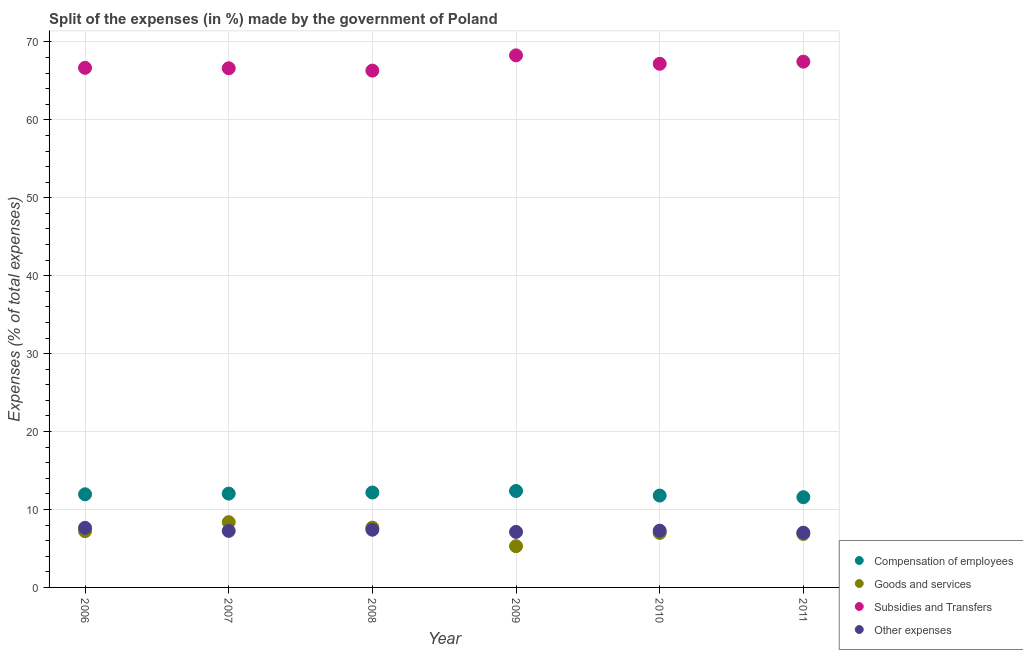Is the number of dotlines equal to the number of legend labels?
Offer a very short reply. Yes. What is the percentage of amount spent on other expenses in 2009?
Provide a succinct answer. 7.13. Across all years, what is the maximum percentage of amount spent on goods and services?
Ensure brevity in your answer.  8.37. Across all years, what is the minimum percentage of amount spent on goods and services?
Offer a very short reply. 5.29. What is the total percentage of amount spent on subsidies in the graph?
Provide a short and direct response. 402.55. What is the difference between the percentage of amount spent on subsidies in 2006 and that in 2011?
Your response must be concise. -0.79. What is the difference between the percentage of amount spent on goods and services in 2011 and the percentage of amount spent on other expenses in 2007?
Your response must be concise. -0.4. What is the average percentage of amount spent on compensation of employees per year?
Offer a terse response. 11.98. In the year 2007, what is the difference between the percentage of amount spent on compensation of employees and percentage of amount spent on subsidies?
Provide a short and direct response. -54.58. What is the ratio of the percentage of amount spent on subsidies in 2007 to that in 2010?
Ensure brevity in your answer.  0.99. Is the difference between the percentage of amount spent on compensation of employees in 2008 and 2009 greater than the difference between the percentage of amount spent on other expenses in 2008 and 2009?
Offer a very short reply. No. What is the difference between the highest and the second highest percentage of amount spent on goods and services?
Your answer should be compact. 0.7. What is the difference between the highest and the lowest percentage of amount spent on other expenses?
Provide a succinct answer. 0.62. In how many years, is the percentage of amount spent on other expenses greater than the average percentage of amount spent on other expenses taken over all years?
Keep it short and to the point. 2. Is the sum of the percentage of amount spent on subsidies in 2009 and 2011 greater than the maximum percentage of amount spent on goods and services across all years?
Ensure brevity in your answer.  Yes. Is it the case that in every year, the sum of the percentage of amount spent on compensation of employees and percentage of amount spent on goods and services is greater than the percentage of amount spent on subsidies?
Offer a terse response. No. Does the percentage of amount spent on subsidies monotonically increase over the years?
Offer a very short reply. No. Is the percentage of amount spent on compensation of employees strictly greater than the percentage of amount spent on subsidies over the years?
Ensure brevity in your answer.  No. Is the percentage of amount spent on subsidies strictly less than the percentage of amount spent on other expenses over the years?
Make the answer very short. No. What is the difference between two consecutive major ticks on the Y-axis?
Offer a very short reply. 10. Are the values on the major ticks of Y-axis written in scientific E-notation?
Give a very brief answer. No. Does the graph contain any zero values?
Your answer should be very brief. No. Does the graph contain grids?
Your answer should be compact. Yes. Where does the legend appear in the graph?
Keep it short and to the point. Bottom right. How many legend labels are there?
Give a very brief answer. 4. How are the legend labels stacked?
Provide a short and direct response. Vertical. What is the title of the graph?
Keep it short and to the point. Split of the expenses (in %) made by the government of Poland. Does "Social Awareness" appear as one of the legend labels in the graph?
Provide a short and direct response. No. What is the label or title of the X-axis?
Your answer should be compact. Year. What is the label or title of the Y-axis?
Make the answer very short. Expenses (% of total expenses). What is the Expenses (% of total expenses) in Compensation of employees in 2006?
Offer a terse response. 11.95. What is the Expenses (% of total expenses) in Goods and services in 2006?
Provide a short and direct response. 7.22. What is the Expenses (% of total expenses) in Subsidies and Transfers in 2006?
Your response must be concise. 66.67. What is the Expenses (% of total expenses) of Other expenses in 2006?
Offer a terse response. 7.64. What is the Expenses (% of total expenses) in Compensation of employees in 2007?
Keep it short and to the point. 12.04. What is the Expenses (% of total expenses) in Goods and services in 2007?
Your answer should be very brief. 8.37. What is the Expenses (% of total expenses) in Subsidies and Transfers in 2007?
Offer a terse response. 66.62. What is the Expenses (% of total expenses) in Other expenses in 2007?
Ensure brevity in your answer.  7.26. What is the Expenses (% of total expenses) in Compensation of employees in 2008?
Your response must be concise. 12.18. What is the Expenses (% of total expenses) in Goods and services in 2008?
Provide a short and direct response. 7.67. What is the Expenses (% of total expenses) in Subsidies and Transfers in 2008?
Ensure brevity in your answer.  66.32. What is the Expenses (% of total expenses) of Other expenses in 2008?
Ensure brevity in your answer.  7.4. What is the Expenses (% of total expenses) in Compensation of employees in 2009?
Your answer should be compact. 12.38. What is the Expenses (% of total expenses) in Goods and services in 2009?
Make the answer very short. 5.29. What is the Expenses (% of total expenses) of Subsidies and Transfers in 2009?
Provide a short and direct response. 68.28. What is the Expenses (% of total expenses) in Other expenses in 2009?
Keep it short and to the point. 7.13. What is the Expenses (% of total expenses) of Compensation of employees in 2010?
Ensure brevity in your answer.  11.79. What is the Expenses (% of total expenses) of Goods and services in 2010?
Make the answer very short. 6.99. What is the Expenses (% of total expenses) in Subsidies and Transfers in 2010?
Your response must be concise. 67.19. What is the Expenses (% of total expenses) in Other expenses in 2010?
Offer a terse response. 7.28. What is the Expenses (% of total expenses) of Compensation of employees in 2011?
Provide a succinct answer. 11.58. What is the Expenses (% of total expenses) of Goods and services in 2011?
Your answer should be compact. 6.86. What is the Expenses (% of total expenses) in Subsidies and Transfers in 2011?
Offer a terse response. 67.47. What is the Expenses (% of total expenses) in Other expenses in 2011?
Make the answer very short. 7.02. Across all years, what is the maximum Expenses (% of total expenses) in Compensation of employees?
Ensure brevity in your answer.  12.38. Across all years, what is the maximum Expenses (% of total expenses) of Goods and services?
Offer a terse response. 8.37. Across all years, what is the maximum Expenses (% of total expenses) of Subsidies and Transfers?
Give a very brief answer. 68.28. Across all years, what is the maximum Expenses (% of total expenses) of Other expenses?
Your answer should be compact. 7.64. Across all years, what is the minimum Expenses (% of total expenses) in Compensation of employees?
Offer a terse response. 11.58. Across all years, what is the minimum Expenses (% of total expenses) in Goods and services?
Offer a terse response. 5.29. Across all years, what is the minimum Expenses (% of total expenses) in Subsidies and Transfers?
Keep it short and to the point. 66.32. Across all years, what is the minimum Expenses (% of total expenses) of Other expenses?
Offer a terse response. 7.02. What is the total Expenses (% of total expenses) in Compensation of employees in the graph?
Provide a short and direct response. 71.91. What is the total Expenses (% of total expenses) of Goods and services in the graph?
Your response must be concise. 42.4. What is the total Expenses (% of total expenses) in Subsidies and Transfers in the graph?
Offer a terse response. 402.55. What is the total Expenses (% of total expenses) in Other expenses in the graph?
Keep it short and to the point. 43.73. What is the difference between the Expenses (% of total expenses) in Compensation of employees in 2006 and that in 2007?
Your answer should be very brief. -0.09. What is the difference between the Expenses (% of total expenses) in Goods and services in 2006 and that in 2007?
Offer a terse response. -1.15. What is the difference between the Expenses (% of total expenses) in Subsidies and Transfers in 2006 and that in 2007?
Provide a succinct answer. 0.05. What is the difference between the Expenses (% of total expenses) in Other expenses in 2006 and that in 2007?
Your response must be concise. 0.39. What is the difference between the Expenses (% of total expenses) of Compensation of employees in 2006 and that in 2008?
Your answer should be compact. -0.23. What is the difference between the Expenses (% of total expenses) of Goods and services in 2006 and that in 2008?
Your answer should be compact. -0.45. What is the difference between the Expenses (% of total expenses) of Subsidies and Transfers in 2006 and that in 2008?
Offer a very short reply. 0.36. What is the difference between the Expenses (% of total expenses) of Other expenses in 2006 and that in 2008?
Make the answer very short. 0.24. What is the difference between the Expenses (% of total expenses) in Compensation of employees in 2006 and that in 2009?
Offer a very short reply. -0.43. What is the difference between the Expenses (% of total expenses) in Goods and services in 2006 and that in 2009?
Your response must be concise. 1.93. What is the difference between the Expenses (% of total expenses) in Subsidies and Transfers in 2006 and that in 2009?
Provide a short and direct response. -1.6. What is the difference between the Expenses (% of total expenses) in Other expenses in 2006 and that in 2009?
Provide a succinct answer. 0.52. What is the difference between the Expenses (% of total expenses) in Compensation of employees in 2006 and that in 2010?
Your response must be concise. 0.16. What is the difference between the Expenses (% of total expenses) in Goods and services in 2006 and that in 2010?
Your answer should be very brief. 0.24. What is the difference between the Expenses (% of total expenses) of Subsidies and Transfers in 2006 and that in 2010?
Keep it short and to the point. -0.52. What is the difference between the Expenses (% of total expenses) in Other expenses in 2006 and that in 2010?
Offer a very short reply. 0.36. What is the difference between the Expenses (% of total expenses) in Compensation of employees in 2006 and that in 2011?
Provide a succinct answer. 0.37. What is the difference between the Expenses (% of total expenses) of Goods and services in 2006 and that in 2011?
Give a very brief answer. 0.36. What is the difference between the Expenses (% of total expenses) in Subsidies and Transfers in 2006 and that in 2011?
Offer a very short reply. -0.79. What is the difference between the Expenses (% of total expenses) in Other expenses in 2006 and that in 2011?
Ensure brevity in your answer.  0.62. What is the difference between the Expenses (% of total expenses) in Compensation of employees in 2007 and that in 2008?
Give a very brief answer. -0.14. What is the difference between the Expenses (% of total expenses) in Goods and services in 2007 and that in 2008?
Keep it short and to the point. 0.7. What is the difference between the Expenses (% of total expenses) in Subsidies and Transfers in 2007 and that in 2008?
Your response must be concise. 0.3. What is the difference between the Expenses (% of total expenses) of Other expenses in 2007 and that in 2008?
Your answer should be very brief. -0.15. What is the difference between the Expenses (% of total expenses) of Compensation of employees in 2007 and that in 2009?
Offer a very short reply. -0.34. What is the difference between the Expenses (% of total expenses) of Goods and services in 2007 and that in 2009?
Give a very brief answer. 3.09. What is the difference between the Expenses (% of total expenses) of Subsidies and Transfers in 2007 and that in 2009?
Ensure brevity in your answer.  -1.65. What is the difference between the Expenses (% of total expenses) in Other expenses in 2007 and that in 2009?
Make the answer very short. 0.13. What is the difference between the Expenses (% of total expenses) in Compensation of employees in 2007 and that in 2010?
Provide a short and direct response. 0.25. What is the difference between the Expenses (% of total expenses) in Goods and services in 2007 and that in 2010?
Your answer should be very brief. 1.39. What is the difference between the Expenses (% of total expenses) in Subsidies and Transfers in 2007 and that in 2010?
Offer a very short reply. -0.57. What is the difference between the Expenses (% of total expenses) in Other expenses in 2007 and that in 2010?
Ensure brevity in your answer.  -0.03. What is the difference between the Expenses (% of total expenses) in Compensation of employees in 2007 and that in 2011?
Provide a short and direct response. 0.46. What is the difference between the Expenses (% of total expenses) in Goods and services in 2007 and that in 2011?
Offer a terse response. 1.52. What is the difference between the Expenses (% of total expenses) in Subsidies and Transfers in 2007 and that in 2011?
Ensure brevity in your answer.  -0.85. What is the difference between the Expenses (% of total expenses) of Other expenses in 2007 and that in 2011?
Your answer should be very brief. 0.23. What is the difference between the Expenses (% of total expenses) of Compensation of employees in 2008 and that in 2009?
Your response must be concise. -0.2. What is the difference between the Expenses (% of total expenses) of Goods and services in 2008 and that in 2009?
Your answer should be compact. 2.38. What is the difference between the Expenses (% of total expenses) in Subsidies and Transfers in 2008 and that in 2009?
Ensure brevity in your answer.  -1.96. What is the difference between the Expenses (% of total expenses) in Other expenses in 2008 and that in 2009?
Your response must be concise. 0.28. What is the difference between the Expenses (% of total expenses) in Compensation of employees in 2008 and that in 2010?
Offer a very short reply. 0.39. What is the difference between the Expenses (% of total expenses) of Goods and services in 2008 and that in 2010?
Offer a very short reply. 0.69. What is the difference between the Expenses (% of total expenses) in Subsidies and Transfers in 2008 and that in 2010?
Offer a terse response. -0.87. What is the difference between the Expenses (% of total expenses) in Other expenses in 2008 and that in 2010?
Offer a very short reply. 0.12. What is the difference between the Expenses (% of total expenses) in Compensation of employees in 2008 and that in 2011?
Your response must be concise. 0.6. What is the difference between the Expenses (% of total expenses) in Goods and services in 2008 and that in 2011?
Your response must be concise. 0.81. What is the difference between the Expenses (% of total expenses) of Subsidies and Transfers in 2008 and that in 2011?
Make the answer very short. -1.15. What is the difference between the Expenses (% of total expenses) of Other expenses in 2008 and that in 2011?
Give a very brief answer. 0.38. What is the difference between the Expenses (% of total expenses) of Compensation of employees in 2009 and that in 2010?
Give a very brief answer. 0.59. What is the difference between the Expenses (% of total expenses) of Goods and services in 2009 and that in 2010?
Provide a short and direct response. -1.7. What is the difference between the Expenses (% of total expenses) in Subsidies and Transfers in 2009 and that in 2010?
Give a very brief answer. 1.08. What is the difference between the Expenses (% of total expenses) in Other expenses in 2009 and that in 2010?
Offer a very short reply. -0.16. What is the difference between the Expenses (% of total expenses) of Compensation of employees in 2009 and that in 2011?
Provide a short and direct response. 0.8. What is the difference between the Expenses (% of total expenses) in Goods and services in 2009 and that in 2011?
Provide a short and direct response. -1.57. What is the difference between the Expenses (% of total expenses) of Subsidies and Transfers in 2009 and that in 2011?
Give a very brief answer. 0.81. What is the difference between the Expenses (% of total expenses) in Other expenses in 2009 and that in 2011?
Your answer should be compact. 0.1. What is the difference between the Expenses (% of total expenses) in Compensation of employees in 2010 and that in 2011?
Your answer should be very brief. 0.21. What is the difference between the Expenses (% of total expenses) of Goods and services in 2010 and that in 2011?
Ensure brevity in your answer.  0.13. What is the difference between the Expenses (% of total expenses) in Subsidies and Transfers in 2010 and that in 2011?
Keep it short and to the point. -0.28. What is the difference between the Expenses (% of total expenses) in Other expenses in 2010 and that in 2011?
Provide a succinct answer. 0.26. What is the difference between the Expenses (% of total expenses) of Compensation of employees in 2006 and the Expenses (% of total expenses) of Goods and services in 2007?
Give a very brief answer. 3.58. What is the difference between the Expenses (% of total expenses) in Compensation of employees in 2006 and the Expenses (% of total expenses) in Subsidies and Transfers in 2007?
Give a very brief answer. -54.67. What is the difference between the Expenses (% of total expenses) of Compensation of employees in 2006 and the Expenses (% of total expenses) of Other expenses in 2007?
Provide a succinct answer. 4.7. What is the difference between the Expenses (% of total expenses) in Goods and services in 2006 and the Expenses (% of total expenses) in Subsidies and Transfers in 2007?
Ensure brevity in your answer.  -59.4. What is the difference between the Expenses (% of total expenses) of Goods and services in 2006 and the Expenses (% of total expenses) of Other expenses in 2007?
Your answer should be compact. -0.03. What is the difference between the Expenses (% of total expenses) in Subsidies and Transfers in 2006 and the Expenses (% of total expenses) in Other expenses in 2007?
Make the answer very short. 59.42. What is the difference between the Expenses (% of total expenses) of Compensation of employees in 2006 and the Expenses (% of total expenses) of Goods and services in 2008?
Offer a very short reply. 4.28. What is the difference between the Expenses (% of total expenses) in Compensation of employees in 2006 and the Expenses (% of total expenses) in Subsidies and Transfers in 2008?
Ensure brevity in your answer.  -54.37. What is the difference between the Expenses (% of total expenses) in Compensation of employees in 2006 and the Expenses (% of total expenses) in Other expenses in 2008?
Offer a very short reply. 4.55. What is the difference between the Expenses (% of total expenses) in Goods and services in 2006 and the Expenses (% of total expenses) in Subsidies and Transfers in 2008?
Offer a terse response. -59.1. What is the difference between the Expenses (% of total expenses) of Goods and services in 2006 and the Expenses (% of total expenses) of Other expenses in 2008?
Your answer should be compact. -0.18. What is the difference between the Expenses (% of total expenses) of Subsidies and Transfers in 2006 and the Expenses (% of total expenses) of Other expenses in 2008?
Your answer should be very brief. 59.27. What is the difference between the Expenses (% of total expenses) of Compensation of employees in 2006 and the Expenses (% of total expenses) of Goods and services in 2009?
Keep it short and to the point. 6.66. What is the difference between the Expenses (% of total expenses) of Compensation of employees in 2006 and the Expenses (% of total expenses) of Subsidies and Transfers in 2009?
Give a very brief answer. -56.32. What is the difference between the Expenses (% of total expenses) of Compensation of employees in 2006 and the Expenses (% of total expenses) of Other expenses in 2009?
Ensure brevity in your answer.  4.83. What is the difference between the Expenses (% of total expenses) in Goods and services in 2006 and the Expenses (% of total expenses) in Subsidies and Transfers in 2009?
Your answer should be very brief. -61.05. What is the difference between the Expenses (% of total expenses) of Goods and services in 2006 and the Expenses (% of total expenses) of Other expenses in 2009?
Provide a succinct answer. 0.1. What is the difference between the Expenses (% of total expenses) in Subsidies and Transfers in 2006 and the Expenses (% of total expenses) in Other expenses in 2009?
Provide a short and direct response. 59.55. What is the difference between the Expenses (% of total expenses) of Compensation of employees in 2006 and the Expenses (% of total expenses) of Goods and services in 2010?
Offer a terse response. 4.96. What is the difference between the Expenses (% of total expenses) in Compensation of employees in 2006 and the Expenses (% of total expenses) in Subsidies and Transfers in 2010?
Keep it short and to the point. -55.24. What is the difference between the Expenses (% of total expenses) in Compensation of employees in 2006 and the Expenses (% of total expenses) in Other expenses in 2010?
Give a very brief answer. 4.67. What is the difference between the Expenses (% of total expenses) of Goods and services in 2006 and the Expenses (% of total expenses) of Subsidies and Transfers in 2010?
Keep it short and to the point. -59.97. What is the difference between the Expenses (% of total expenses) of Goods and services in 2006 and the Expenses (% of total expenses) of Other expenses in 2010?
Offer a very short reply. -0.06. What is the difference between the Expenses (% of total expenses) of Subsidies and Transfers in 2006 and the Expenses (% of total expenses) of Other expenses in 2010?
Give a very brief answer. 59.39. What is the difference between the Expenses (% of total expenses) of Compensation of employees in 2006 and the Expenses (% of total expenses) of Goods and services in 2011?
Your answer should be very brief. 5.09. What is the difference between the Expenses (% of total expenses) of Compensation of employees in 2006 and the Expenses (% of total expenses) of Subsidies and Transfers in 2011?
Ensure brevity in your answer.  -55.52. What is the difference between the Expenses (% of total expenses) in Compensation of employees in 2006 and the Expenses (% of total expenses) in Other expenses in 2011?
Your answer should be compact. 4.93. What is the difference between the Expenses (% of total expenses) of Goods and services in 2006 and the Expenses (% of total expenses) of Subsidies and Transfers in 2011?
Your response must be concise. -60.25. What is the difference between the Expenses (% of total expenses) in Goods and services in 2006 and the Expenses (% of total expenses) in Other expenses in 2011?
Give a very brief answer. 0.2. What is the difference between the Expenses (% of total expenses) of Subsidies and Transfers in 2006 and the Expenses (% of total expenses) of Other expenses in 2011?
Offer a terse response. 59.65. What is the difference between the Expenses (% of total expenses) in Compensation of employees in 2007 and the Expenses (% of total expenses) in Goods and services in 2008?
Make the answer very short. 4.36. What is the difference between the Expenses (% of total expenses) in Compensation of employees in 2007 and the Expenses (% of total expenses) in Subsidies and Transfers in 2008?
Provide a succinct answer. -54.28. What is the difference between the Expenses (% of total expenses) of Compensation of employees in 2007 and the Expenses (% of total expenses) of Other expenses in 2008?
Offer a very short reply. 4.63. What is the difference between the Expenses (% of total expenses) in Goods and services in 2007 and the Expenses (% of total expenses) in Subsidies and Transfers in 2008?
Make the answer very short. -57.94. What is the difference between the Expenses (% of total expenses) in Goods and services in 2007 and the Expenses (% of total expenses) in Other expenses in 2008?
Provide a succinct answer. 0.97. What is the difference between the Expenses (% of total expenses) in Subsidies and Transfers in 2007 and the Expenses (% of total expenses) in Other expenses in 2008?
Your answer should be compact. 59.22. What is the difference between the Expenses (% of total expenses) in Compensation of employees in 2007 and the Expenses (% of total expenses) in Goods and services in 2009?
Give a very brief answer. 6.75. What is the difference between the Expenses (% of total expenses) in Compensation of employees in 2007 and the Expenses (% of total expenses) in Subsidies and Transfers in 2009?
Your answer should be very brief. -56.24. What is the difference between the Expenses (% of total expenses) of Compensation of employees in 2007 and the Expenses (% of total expenses) of Other expenses in 2009?
Ensure brevity in your answer.  4.91. What is the difference between the Expenses (% of total expenses) of Goods and services in 2007 and the Expenses (% of total expenses) of Subsidies and Transfers in 2009?
Make the answer very short. -59.9. What is the difference between the Expenses (% of total expenses) in Goods and services in 2007 and the Expenses (% of total expenses) in Other expenses in 2009?
Give a very brief answer. 1.25. What is the difference between the Expenses (% of total expenses) of Subsidies and Transfers in 2007 and the Expenses (% of total expenses) of Other expenses in 2009?
Make the answer very short. 59.5. What is the difference between the Expenses (% of total expenses) in Compensation of employees in 2007 and the Expenses (% of total expenses) in Goods and services in 2010?
Offer a terse response. 5.05. What is the difference between the Expenses (% of total expenses) of Compensation of employees in 2007 and the Expenses (% of total expenses) of Subsidies and Transfers in 2010?
Offer a terse response. -55.15. What is the difference between the Expenses (% of total expenses) in Compensation of employees in 2007 and the Expenses (% of total expenses) in Other expenses in 2010?
Your answer should be very brief. 4.76. What is the difference between the Expenses (% of total expenses) of Goods and services in 2007 and the Expenses (% of total expenses) of Subsidies and Transfers in 2010?
Provide a succinct answer. -58.82. What is the difference between the Expenses (% of total expenses) of Goods and services in 2007 and the Expenses (% of total expenses) of Other expenses in 2010?
Offer a terse response. 1.09. What is the difference between the Expenses (% of total expenses) in Subsidies and Transfers in 2007 and the Expenses (% of total expenses) in Other expenses in 2010?
Provide a short and direct response. 59.34. What is the difference between the Expenses (% of total expenses) in Compensation of employees in 2007 and the Expenses (% of total expenses) in Goods and services in 2011?
Your answer should be very brief. 5.18. What is the difference between the Expenses (% of total expenses) in Compensation of employees in 2007 and the Expenses (% of total expenses) in Subsidies and Transfers in 2011?
Ensure brevity in your answer.  -55.43. What is the difference between the Expenses (% of total expenses) in Compensation of employees in 2007 and the Expenses (% of total expenses) in Other expenses in 2011?
Make the answer very short. 5.01. What is the difference between the Expenses (% of total expenses) of Goods and services in 2007 and the Expenses (% of total expenses) of Subsidies and Transfers in 2011?
Keep it short and to the point. -59.09. What is the difference between the Expenses (% of total expenses) in Goods and services in 2007 and the Expenses (% of total expenses) in Other expenses in 2011?
Your answer should be very brief. 1.35. What is the difference between the Expenses (% of total expenses) in Subsidies and Transfers in 2007 and the Expenses (% of total expenses) in Other expenses in 2011?
Ensure brevity in your answer.  59.6. What is the difference between the Expenses (% of total expenses) of Compensation of employees in 2008 and the Expenses (% of total expenses) of Goods and services in 2009?
Offer a terse response. 6.89. What is the difference between the Expenses (% of total expenses) of Compensation of employees in 2008 and the Expenses (% of total expenses) of Subsidies and Transfers in 2009?
Offer a terse response. -56.1. What is the difference between the Expenses (% of total expenses) of Compensation of employees in 2008 and the Expenses (% of total expenses) of Other expenses in 2009?
Make the answer very short. 5.05. What is the difference between the Expenses (% of total expenses) in Goods and services in 2008 and the Expenses (% of total expenses) in Subsidies and Transfers in 2009?
Offer a very short reply. -60.6. What is the difference between the Expenses (% of total expenses) in Goods and services in 2008 and the Expenses (% of total expenses) in Other expenses in 2009?
Your answer should be very brief. 0.55. What is the difference between the Expenses (% of total expenses) in Subsidies and Transfers in 2008 and the Expenses (% of total expenses) in Other expenses in 2009?
Provide a short and direct response. 59.19. What is the difference between the Expenses (% of total expenses) in Compensation of employees in 2008 and the Expenses (% of total expenses) in Goods and services in 2010?
Provide a short and direct response. 5.19. What is the difference between the Expenses (% of total expenses) in Compensation of employees in 2008 and the Expenses (% of total expenses) in Subsidies and Transfers in 2010?
Your response must be concise. -55.01. What is the difference between the Expenses (% of total expenses) of Compensation of employees in 2008 and the Expenses (% of total expenses) of Other expenses in 2010?
Ensure brevity in your answer.  4.9. What is the difference between the Expenses (% of total expenses) in Goods and services in 2008 and the Expenses (% of total expenses) in Subsidies and Transfers in 2010?
Your response must be concise. -59.52. What is the difference between the Expenses (% of total expenses) in Goods and services in 2008 and the Expenses (% of total expenses) in Other expenses in 2010?
Ensure brevity in your answer.  0.39. What is the difference between the Expenses (% of total expenses) in Subsidies and Transfers in 2008 and the Expenses (% of total expenses) in Other expenses in 2010?
Make the answer very short. 59.04. What is the difference between the Expenses (% of total expenses) of Compensation of employees in 2008 and the Expenses (% of total expenses) of Goods and services in 2011?
Your answer should be very brief. 5.32. What is the difference between the Expenses (% of total expenses) in Compensation of employees in 2008 and the Expenses (% of total expenses) in Subsidies and Transfers in 2011?
Keep it short and to the point. -55.29. What is the difference between the Expenses (% of total expenses) of Compensation of employees in 2008 and the Expenses (% of total expenses) of Other expenses in 2011?
Keep it short and to the point. 5.15. What is the difference between the Expenses (% of total expenses) in Goods and services in 2008 and the Expenses (% of total expenses) in Subsidies and Transfers in 2011?
Provide a short and direct response. -59.8. What is the difference between the Expenses (% of total expenses) in Goods and services in 2008 and the Expenses (% of total expenses) in Other expenses in 2011?
Provide a short and direct response. 0.65. What is the difference between the Expenses (% of total expenses) in Subsidies and Transfers in 2008 and the Expenses (% of total expenses) in Other expenses in 2011?
Provide a succinct answer. 59.3. What is the difference between the Expenses (% of total expenses) in Compensation of employees in 2009 and the Expenses (% of total expenses) in Goods and services in 2010?
Give a very brief answer. 5.39. What is the difference between the Expenses (% of total expenses) of Compensation of employees in 2009 and the Expenses (% of total expenses) of Subsidies and Transfers in 2010?
Give a very brief answer. -54.82. What is the difference between the Expenses (% of total expenses) in Compensation of employees in 2009 and the Expenses (% of total expenses) in Other expenses in 2010?
Your answer should be compact. 5.1. What is the difference between the Expenses (% of total expenses) in Goods and services in 2009 and the Expenses (% of total expenses) in Subsidies and Transfers in 2010?
Keep it short and to the point. -61.9. What is the difference between the Expenses (% of total expenses) in Goods and services in 2009 and the Expenses (% of total expenses) in Other expenses in 2010?
Offer a very short reply. -1.99. What is the difference between the Expenses (% of total expenses) in Subsidies and Transfers in 2009 and the Expenses (% of total expenses) in Other expenses in 2010?
Provide a succinct answer. 60.99. What is the difference between the Expenses (% of total expenses) of Compensation of employees in 2009 and the Expenses (% of total expenses) of Goods and services in 2011?
Your response must be concise. 5.52. What is the difference between the Expenses (% of total expenses) in Compensation of employees in 2009 and the Expenses (% of total expenses) in Subsidies and Transfers in 2011?
Your answer should be very brief. -55.09. What is the difference between the Expenses (% of total expenses) of Compensation of employees in 2009 and the Expenses (% of total expenses) of Other expenses in 2011?
Your answer should be compact. 5.35. What is the difference between the Expenses (% of total expenses) of Goods and services in 2009 and the Expenses (% of total expenses) of Subsidies and Transfers in 2011?
Make the answer very short. -62.18. What is the difference between the Expenses (% of total expenses) in Goods and services in 2009 and the Expenses (% of total expenses) in Other expenses in 2011?
Offer a terse response. -1.74. What is the difference between the Expenses (% of total expenses) in Subsidies and Transfers in 2009 and the Expenses (% of total expenses) in Other expenses in 2011?
Provide a succinct answer. 61.25. What is the difference between the Expenses (% of total expenses) in Compensation of employees in 2010 and the Expenses (% of total expenses) in Goods and services in 2011?
Ensure brevity in your answer.  4.93. What is the difference between the Expenses (% of total expenses) of Compensation of employees in 2010 and the Expenses (% of total expenses) of Subsidies and Transfers in 2011?
Provide a succinct answer. -55.68. What is the difference between the Expenses (% of total expenses) of Compensation of employees in 2010 and the Expenses (% of total expenses) of Other expenses in 2011?
Make the answer very short. 4.76. What is the difference between the Expenses (% of total expenses) in Goods and services in 2010 and the Expenses (% of total expenses) in Subsidies and Transfers in 2011?
Make the answer very short. -60.48. What is the difference between the Expenses (% of total expenses) of Goods and services in 2010 and the Expenses (% of total expenses) of Other expenses in 2011?
Ensure brevity in your answer.  -0.04. What is the difference between the Expenses (% of total expenses) in Subsidies and Transfers in 2010 and the Expenses (% of total expenses) in Other expenses in 2011?
Provide a succinct answer. 60.17. What is the average Expenses (% of total expenses) in Compensation of employees per year?
Offer a terse response. 11.98. What is the average Expenses (% of total expenses) of Goods and services per year?
Your answer should be very brief. 7.07. What is the average Expenses (% of total expenses) of Subsidies and Transfers per year?
Offer a very short reply. 67.09. What is the average Expenses (% of total expenses) of Other expenses per year?
Keep it short and to the point. 7.29. In the year 2006, what is the difference between the Expenses (% of total expenses) of Compensation of employees and Expenses (% of total expenses) of Goods and services?
Your response must be concise. 4.73. In the year 2006, what is the difference between the Expenses (% of total expenses) in Compensation of employees and Expenses (% of total expenses) in Subsidies and Transfers?
Ensure brevity in your answer.  -54.72. In the year 2006, what is the difference between the Expenses (% of total expenses) of Compensation of employees and Expenses (% of total expenses) of Other expenses?
Your response must be concise. 4.31. In the year 2006, what is the difference between the Expenses (% of total expenses) in Goods and services and Expenses (% of total expenses) in Subsidies and Transfers?
Provide a short and direct response. -59.45. In the year 2006, what is the difference between the Expenses (% of total expenses) in Goods and services and Expenses (% of total expenses) in Other expenses?
Provide a succinct answer. -0.42. In the year 2006, what is the difference between the Expenses (% of total expenses) of Subsidies and Transfers and Expenses (% of total expenses) of Other expenses?
Your response must be concise. 59.03. In the year 2007, what is the difference between the Expenses (% of total expenses) of Compensation of employees and Expenses (% of total expenses) of Goods and services?
Keep it short and to the point. 3.66. In the year 2007, what is the difference between the Expenses (% of total expenses) of Compensation of employees and Expenses (% of total expenses) of Subsidies and Transfers?
Make the answer very short. -54.58. In the year 2007, what is the difference between the Expenses (% of total expenses) in Compensation of employees and Expenses (% of total expenses) in Other expenses?
Your response must be concise. 4.78. In the year 2007, what is the difference between the Expenses (% of total expenses) of Goods and services and Expenses (% of total expenses) of Subsidies and Transfers?
Your answer should be very brief. -58.25. In the year 2007, what is the difference between the Expenses (% of total expenses) in Goods and services and Expenses (% of total expenses) in Other expenses?
Your answer should be compact. 1.12. In the year 2007, what is the difference between the Expenses (% of total expenses) in Subsidies and Transfers and Expenses (% of total expenses) in Other expenses?
Make the answer very short. 59.37. In the year 2008, what is the difference between the Expenses (% of total expenses) in Compensation of employees and Expenses (% of total expenses) in Goods and services?
Ensure brevity in your answer.  4.51. In the year 2008, what is the difference between the Expenses (% of total expenses) in Compensation of employees and Expenses (% of total expenses) in Subsidies and Transfers?
Provide a succinct answer. -54.14. In the year 2008, what is the difference between the Expenses (% of total expenses) of Compensation of employees and Expenses (% of total expenses) of Other expenses?
Your answer should be very brief. 4.77. In the year 2008, what is the difference between the Expenses (% of total expenses) in Goods and services and Expenses (% of total expenses) in Subsidies and Transfers?
Keep it short and to the point. -58.65. In the year 2008, what is the difference between the Expenses (% of total expenses) in Goods and services and Expenses (% of total expenses) in Other expenses?
Make the answer very short. 0.27. In the year 2008, what is the difference between the Expenses (% of total expenses) in Subsidies and Transfers and Expenses (% of total expenses) in Other expenses?
Offer a very short reply. 58.91. In the year 2009, what is the difference between the Expenses (% of total expenses) of Compensation of employees and Expenses (% of total expenses) of Goods and services?
Offer a very short reply. 7.09. In the year 2009, what is the difference between the Expenses (% of total expenses) in Compensation of employees and Expenses (% of total expenses) in Subsidies and Transfers?
Your answer should be compact. -55.9. In the year 2009, what is the difference between the Expenses (% of total expenses) of Compensation of employees and Expenses (% of total expenses) of Other expenses?
Provide a short and direct response. 5.25. In the year 2009, what is the difference between the Expenses (% of total expenses) of Goods and services and Expenses (% of total expenses) of Subsidies and Transfers?
Make the answer very short. -62.99. In the year 2009, what is the difference between the Expenses (% of total expenses) of Goods and services and Expenses (% of total expenses) of Other expenses?
Your answer should be very brief. -1.84. In the year 2009, what is the difference between the Expenses (% of total expenses) in Subsidies and Transfers and Expenses (% of total expenses) in Other expenses?
Your answer should be compact. 61.15. In the year 2010, what is the difference between the Expenses (% of total expenses) in Compensation of employees and Expenses (% of total expenses) in Goods and services?
Your response must be concise. 4.8. In the year 2010, what is the difference between the Expenses (% of total expenses) of Compensation of employees and Expenses (% of total expenses) of Subsidies and Transfers?
Offer a terse response. -55.4. In the year 2010, what is the difference between the Expenses (% of total expenses) of Compensation of employees and Expenses (% of total expenses) of Other expenses?
Your answer should be compact. 4.51. In the year 2010, what is the difference between the Expenses (% of total expenses) of Goods and services and Expenses (% of total expenses) of Subsidies and Transfers?
Your response must be concise. -60.21. In the year 2010, what is the difference between the Expenses (% of total expenses) of Goods and services and Expenses (% of total expenses) of Other expenses?
Provide a short and direct response. -0.29. In the year 2010, what is the difference between the Expenses (% of total expenses) of Subsidies and Transfers and Expenses (% of total expenses) of Other expenses?
Ensure brevity in your answer.  59.91. In the year 2011, what is the difference between the Expenses (% of total expenses) in Compensation of employees and Expenses (% of total expenses) in Goods and services?
Provide a succinct answer. 4.72. In the year 2011, what is the difference between the Expenses (% of total expenses) of Compensation of employees and Expenses (% of total expenses) of Subsidies and Transfers?
Your answer should be compact. -55.89. In the year 2011, what is the difference between the Expenses (% of total expenses) in Compensation of employees and Expenses (% of total expenses) in Other expenses?
Offer a very short reply. 4.55. In the year 2011, what is the difference between the Expenses (% of total expenses) of Goods and services and Expenses (% of total expenses) of Subsidies and Transfers?
Make the answer very short. -60.61. In the year 2011, what is the difference between the Expenses (% of total expenses) of Goods and services and Expenses (% of total expenses) of Other expenses?
Provide a short and direct response. -0.17. In the year 2011, what is the difference between the Expenses (% of total expenses) of Subsidies and Transfers and Expenses (% of total expenses) of Other expenses?
Offer a terse response. 60.45. What is the ratio of the Expenses (% of total expenses) in Compensation of employees in 2006 to that in 2007?
Keep it short and to the point. 0.99. What is the ratio of the Expenses (% of total expenses) in Goods and services in 2006 to that in 2007?
Keep it short and to the point. 0.86. What is the ratio of the Expenses (% of total expenses) of Other expenses in 2006 to that in 2007?
Give a very brief answer. 1.05. What is the ratio of the Expenses (% of total expenses) of Compensation of employees in 2006 to that in 2008?
Provide a short and direct response. 0.98. What is the ratio of the Expenses (% of total expenses) of Subsidies and Transfers in 2006 to that in 2008?
Make the answer very short. 1.01. What is the ratio of the Expenses (% of total expenses) in Other expenses in 2006 to that in 2008?
Give a very brief answer. 1.03. What is the ratio of the Expenses (% of total expenses) of Compensation of employees in 2006 to that in 2009?
Provide a short and direct response. 0.97. What is the ratio of the Expenses (% of total expenses) in Goods and services in 2006 to that in 2009?
Your answer should be compact. 1.37. What is the ratio of the Expenses (% of total expenses) of Subsidies and Transfers in 2006 to that in 2009?
Offer a very short reply. 0.98. What is the ratio of the Expenses (% of total expenses) of Other expenses in 2006 to that in 2009?
Ensure brevity in your answer.  1.07. What is the ratio of the Expenses (% of total expenses) of Compensation of employees in 2006 to that in 2010?
Provide a succinct answer. 1.01. What is the ratio of the Expenses (% of total expenses) in Goods and services in 2006 to that in 2010?
Your answer should be very brief. 1.03. What is the ratio of the Expenses (% of total expenses) in Subsidies and Transfers in 2006 to that in 2010?
Ensure brevity in your answer.  0.99. What is the ratio of the Expenses (% of total expenses) in Other expenses in 2006 to that in 2010?
Ensure brevity in your answer.  1.05. What is the ratio of the Expenses (% of total expenses) in Compensation of employees in 2006 to that in 2011?
Keep it short and to the point. 1.03. What is the ratio of the Expenses (% of total expenses) in Goods and services in 2006 to that in 2011?
Make the answer very short. 1.05. What is the ratio of the Expenses (% of total expenses) of Subsidies and Transfers in 2006 to that in 2011?
Keep it short and to the point. 0.99. What is the ratio of the Expenses (% of total expenses) of Other expenses in 2006 to that in 2011?
Ensure brevity in your answer.  1.09. What is the ratio of the Expenses (% of total expenses) of Compensation of employees in 2007 to that in 2008?
Provide a short and direct response. 0.99. What is the ratio of the Expenses (% of total expenses) in Goods and services in 2007 to that in 2008?
Make the answer very short. 1.09. What is the ratio of the Expenses (% of total expenses) in Other expenses in 2007 to that in 2008?
Offer a terse response. 0.98. What is the ratio of the Expenses (% of total expenses) of Compensation of employees in 2007 to that in 2009?
Ensure brevity in your answer.  0.97. What is the ratio of the Expenses (% of total expenses) of Goods and services in 2007 to that in 2009?
Your answer should be very brief. 1.58. What is the ratio of the Expenses (% of total expenses) in Subsidies and Transfers in 2007 to that in 2009?
Your answer should be very brief. 0.98. What is the ratio of the Expenses (% of total expenses) of Other expenses in 2007 to that in 2009?
Ensure brevity in your answer.  1.02. What is the ratio of the Expenses (% of total expenses) in Compensation of employees in 2007 to that in 2010?
Make the answer very short. 1.02. What is the ratio of the Expenses (% of total expenses) of Goods and services in 2007 to that in 2010?
Provide a succinct answer. 1.2. What is the ratio of the Expenses (% of total expenses) in Subsidies and Transfers in 2007 to that in 2010?
Offer a terse response. 0.99. What is the ratio of the Expenses (% of total expenses) in Other expenses in 2007 to that in 2010?
Your answer should be compact. 1. What is the ratio of the Expenses (% of total expenses) of Compensation of employees in 2007 to that in 2011?
Your answer should be very brief. 1.04. What is the ratio of the Expenses (% of total expenses) of Goods and services in 2007 to that in 2011?
Offer a very short reply. 1.22. What is the ratio of the Expenses (% of total expenses) in Subsidies and Transfers in 2007 to that in 2011?
Keep it short and to the point. 0.99. What is the ratio of the Expenses (% of total expenses) in Other expenses in 2007 to that in 2011?
Offer a very short reply. 1.03. What is the ratio of the Expenses (% of total expenses) in Goods and services in 2008 to that in 2009?
Offer a very short reply. 1.45. What is the ratio of the Expenses (% of total expenses) in Subsidies and Transfers in 2008 to that in 2009?
Ensure brevity in your answer.  0.97. What is the ratio of the Expenses (% of total expenses) of Other expenses in 2008 to that in 2009?
Give a very brief answer. 1.04. What is the ratio of the Expenses (% of total expenses) in Compensation of employees in 2008 to that in 2010?
Your response must be concise. 1.03. What is the ratio of the Expenses (% of total expenses) of Goods and services in 2008 to that in 2010?
Make the answer very short. 1.1. What is the ratio of the Expenses (% of total expenses) of Subsidies and Transfers in 2008 to that in 2010?
Offer a very short reply. 0.99. What is the ratio of the Expenses (% of total expenses) in Other expenses in 2008 to that in 2010?
Give a very brief answer. 1.02. What is the ratio of the Expenses (% of total expenses) of Compensation of employees in 2008 to that in 2011?
Provide a succinct answer. 1.05. What is the ratio of the Expenses (% of total expenses) of Goods and services in 2008 to that in 2011?
Give a very brief answer. 1.12. What is the ratio of the Expenses (% of total expenses) in Other expenses in 2008 to that in 2011?
Provide a short and direct response. 1.05. What is the ratio of the Expenses (% of total expenses) of Goods and services in 2009 to that in 2010?
Keep it short and to the point. 0.76. What is the ratio of the Expenses (% of total expenses) of Subsidies and Transfers in 2009 to that in 2010?
Your answer should be very brief. 1.02. What is the ratio of the Expenses (% of total expenses) of Other expenses in 2009 to that in 2010?
Ensure brevity in your answer.  0.98. What is the ratio of the Expenses (% of total expenses) of Compensation of employees in 2009 to that in 2011?
Offer a terse response. 1.07. What is the ratio of the Expenses (% of total expenses) of Goods and services in 2009 to that in 2011?
Offer a terse response. 0.77. What is the ratio of the Expenses (% of total expenses) in Subsidies and Transfers in 2009 to that in 2011?
Give a very brief answer. 1.01. What is the ratio of the Expenses (% of total expenses) in Other expenses in 2009 to that in 2011?
Give a very brief answer. 1.01. What is the ratio of the Expenses (% of total expenses) of Compensation of employees in 2010 to that in 2011?
Keep it short and to the point. 1.02. What is the ratio of the Expenses (% of total expenses) of Goods and services in 2010 to that in 2011?
Keep it short and to the point. 1.02. What is the ratio of the Expenses (% of total expenses) in Subsidies and Transfers in 2010 to that in 2011?
Keep it short and to the point. 1. What is the ratio of the Expenses (% of total expenses) in Other expenses in 2010 to that in 2011?
Provide a succinct answer. 1.04. What is the difference between the highest and the second highest Expenses (% of total expenses) of Compensation of employees?
Give a very brief answer. 0.2. What is the difference between the highest and the second highest Expenses (% of total expenses) in Goods and services?
Provide a succinct answer. 0.7. What is the difference between the highest and the second highest Expenses (% of total expenses) of Subsidies and Transfers?
Provide a short and direct response. 0.81. What is the difference between the highest and the second highest Expenses (% of total expenses) in Other expenses?
Make the answer very short. 0.24. What is the difference between the highest and the lowest Expenses (% of total expenses) in Compensation of employees?
Your response must be concise. 0.8. What is the difference between the highest and the lowest Expenses (% of total expenses) in Goods and services?
Your response must be concise. 3.09. What is the difference between the highest and the lowest Expenses (% of total expenses) of Subsidies and Transfers?
Your response must be concise. 1.96. What is the difference between the highest and the lowest Expenses (% of total expenses) of Other expenses?
Your answer should be compact. 0.62. 